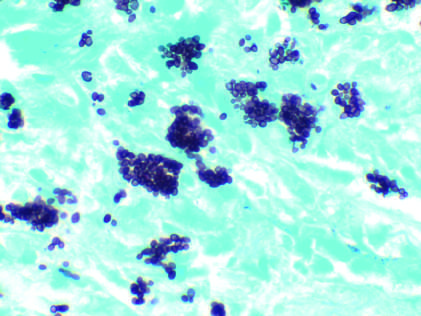what fills phagocytes in a lymph node of a patient with disseminated histoplasmosis?
Answer the question using a single word or phrase. Histoplasma capsulatum yeast forms 